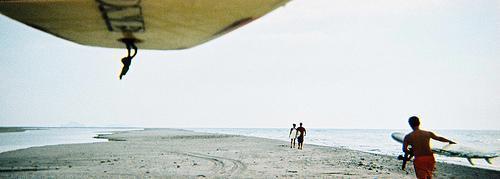How many people in the picture?
Give a very brief answer. 3. 